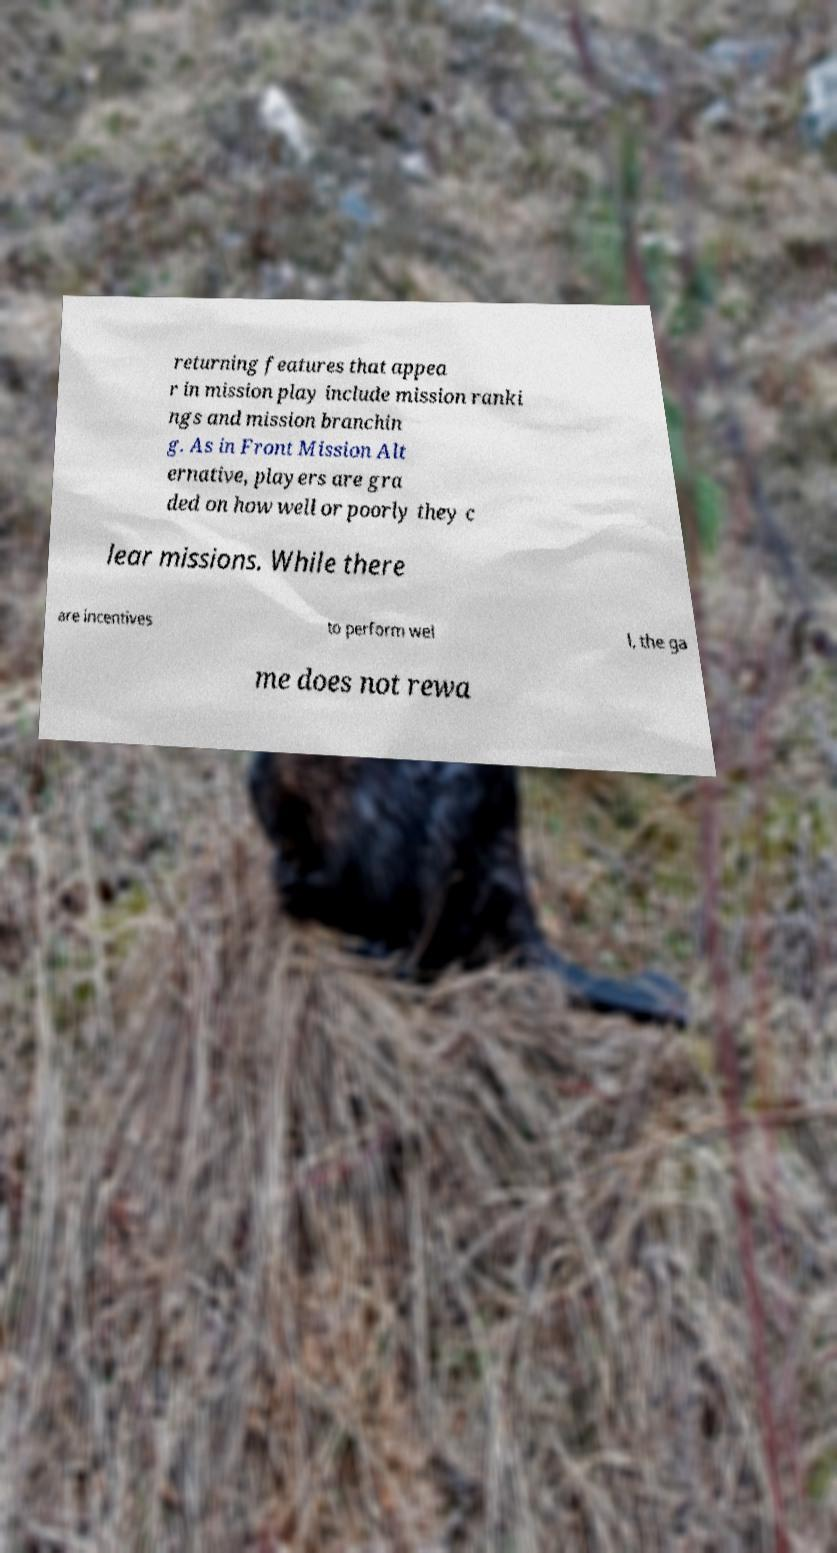I need the written content from this picture converted into text. Can you do that? returning features that appea r in mission play include mission ranki ngs and mission branchin g. As in Front Mission Alt ernative, players are gra ded on how well or poorly they c lear missions. While there are incentives to perform wel l, the ga me does not rewa 